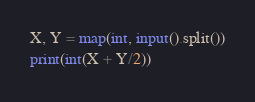Convert code to text. <code><loc_0><loc_0><loc_500><loc_500><_Python_>X, Y = map(int, input().split())
print(int(X + Y/2))</code> 